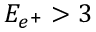Convert formula to latex. <formula><loc_0><loc_0><loc_500><loc_500>E _ { e ^ { + } } > 3</formula> 